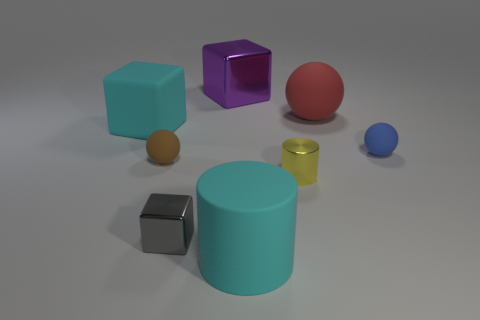Subtract all tiny balls. How many balls are left? 1 Subtract all purple cubes. How many cubes are left? 2 Subtract all cubes. How many objects are left? 5 Subtract all cyan rubber blocks. Subtract all small purple matte objects. How many objects are left? 7 Add 5 purple metal blocks. How many purple metal blocks are left? 6 Add 8 purple metal things. How many purple metal things exist? 9 Add 2 red balls. How many objects exist? 10 Subtract 0 red cylinders. How many objects are left? 8 Subtract 2 cylinders. How many cylinders are left? 0 Subtract all yellow cylinders. Subtract all green spheres. How many cylinders are left? 1 